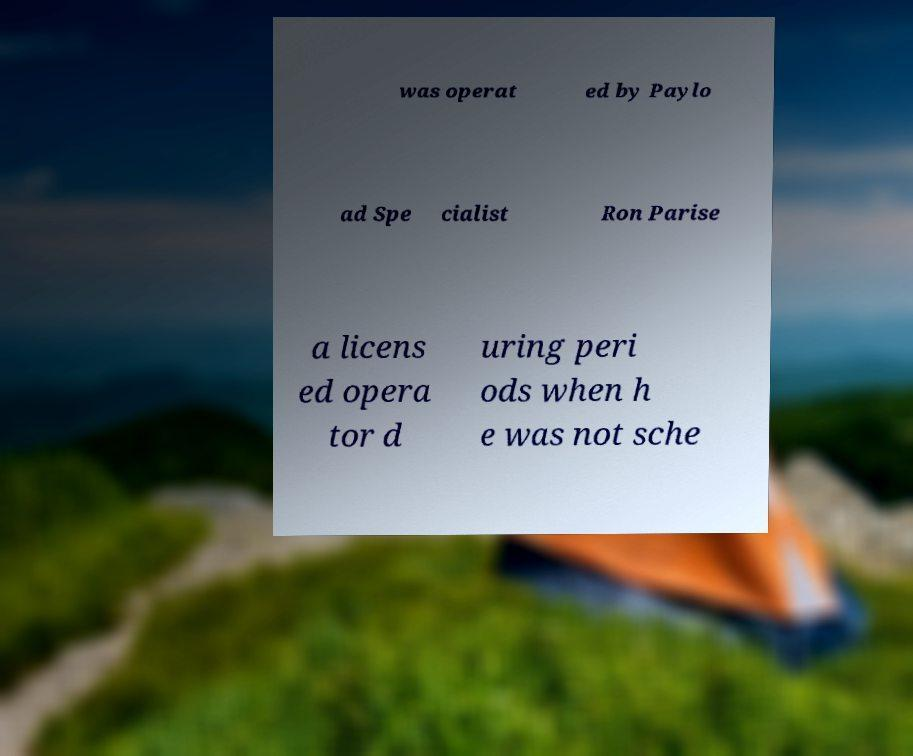I need the written content from this picture converted into text. Can you do that? was operat ed by Paylo ad Spe cialist Ron Parise a licens ed opera tor d uring peri ods when h e was not sche 